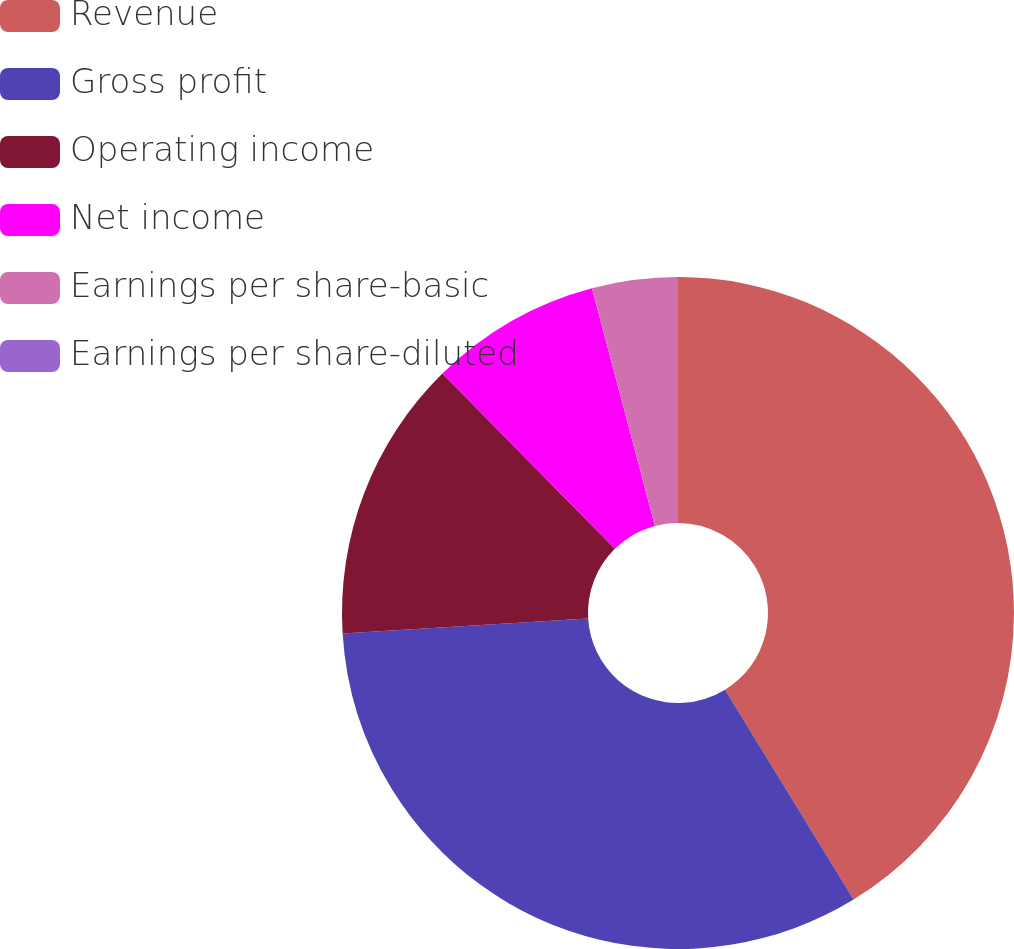Convert chart. <chart><loc_0><loc_0><loc_500><loc_500><pie_chart><fcel>Revenue<fcel>Gross profit<fcel>Operating income<fcel>Net income<fcel>Earnings per share-basic<fcel>Earnings per share-diluted<nl><fcel>41.25%<fcel>32.78%<fcel>13.6%<fcel>8.25%<fcel>4.12%<fcel>0.0%<nl></chart> 